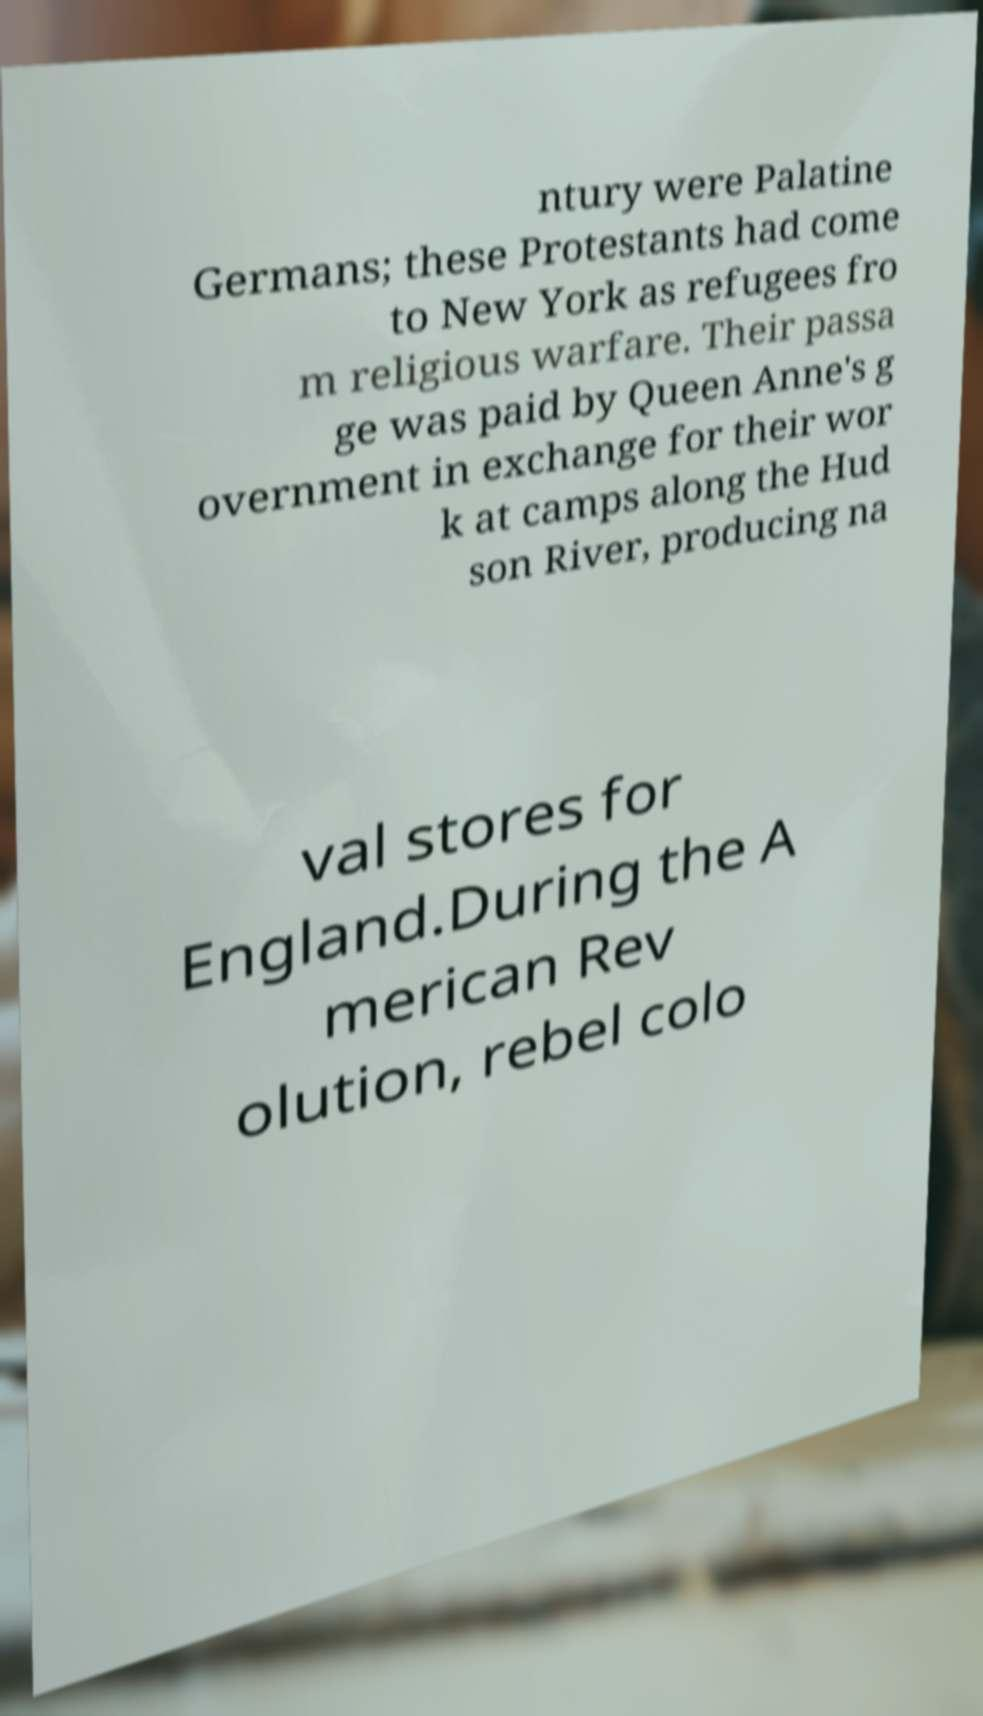Can you read and provide the text displayed in the image?This photo seems to have some interesting text. Can you extract and type it out for me? ntury were Palatine Germans; these Protestants had come to New York as refugees fro m religious warfare. Their passa ge was paid by Queen Anne's g overnment in exchange for their wor k at camps along the Hud son River, producing na val stores for England.During the A merican Rev olution, rebel colo 